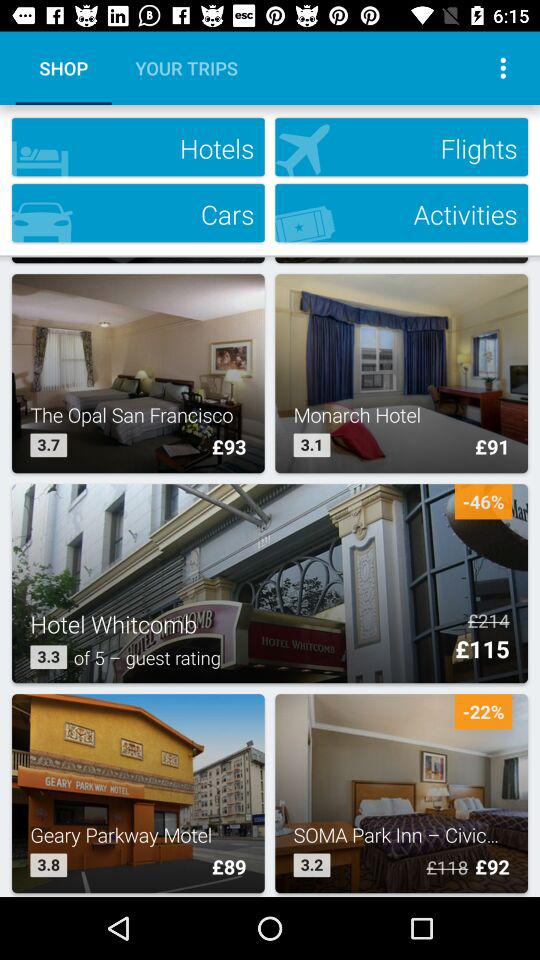What is the booking price of a room at the "Monarch Hotel"? The booking price is £91. 